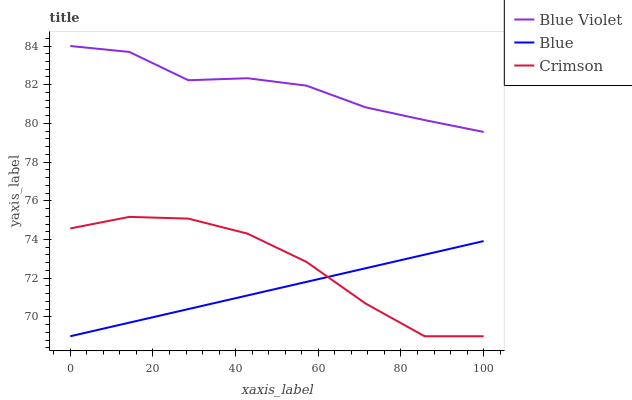Does Crimson have the minimum area under the curve?
Answer yes or no. No. Does Crimson have the maximum area under the curve?
Answer yes or no. No. Is Blue Violet the smoothest?
Answer yes or no. No. Is Blue Violet the roughest?
Answer yes or no. No. Does Blue Violet have the lowest value?
Answer yes or no. No. Does Crimson have the highest value?
Answer yes or no. No. Is Blue less than Blue Violet?
Answer yes or no. Yes. Is Blue Violet greater than Crimson?
Answer yes or no. Yes. Does Blue intersect Blue Violet?
Answer yes or no. No. 